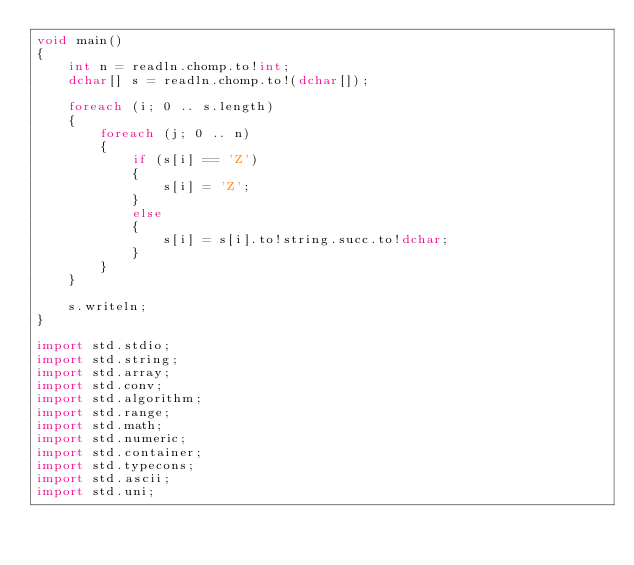<code> <loc_0><loc_0><loc_500><loc_500><_D_>void main()
{
    int n = readln.chomp.to!int;
    dchar[] s = readln.chomp.to!(dchar[]);

    foreach (i; 0 .. s.length)
    {
        foreach (j; 0 .. n)
        {
            if (s[i] == 'Z')
            {
                s[i] = 'Z';
            }
            else
            {
                s[i] = s[i].to!string.succ.to!dchar;
            }
        }
    }

    s.writeln;
}

import std.stdio;
import std.string;
import std.array;
import std.conv;
import std.algorithm;
import std.range;
import std.math;
import std.numeric;
import std.container;
import std.typecons;
import std.ascii;
import std.uni;</code> 